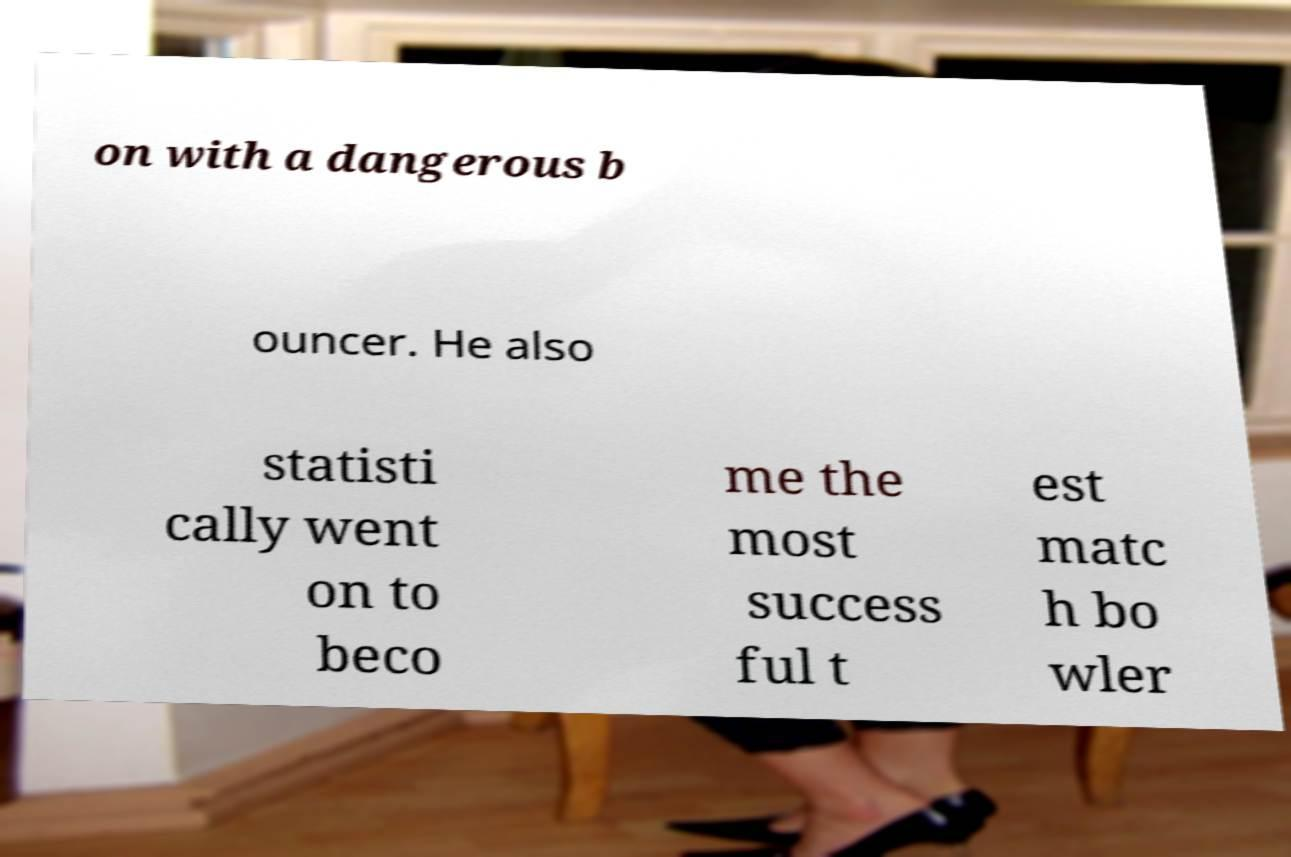What messages or text are displayed in this image? I need them in a readable, typed format. on with a dangerous b ouncer. He also statisti cally went on to beco me the most success ful t est matc h bo wler 